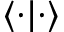<formula> <loc_0><loc_0><loc_500><loc_500>\langle \cdot | \cdot \rangle</formula> 